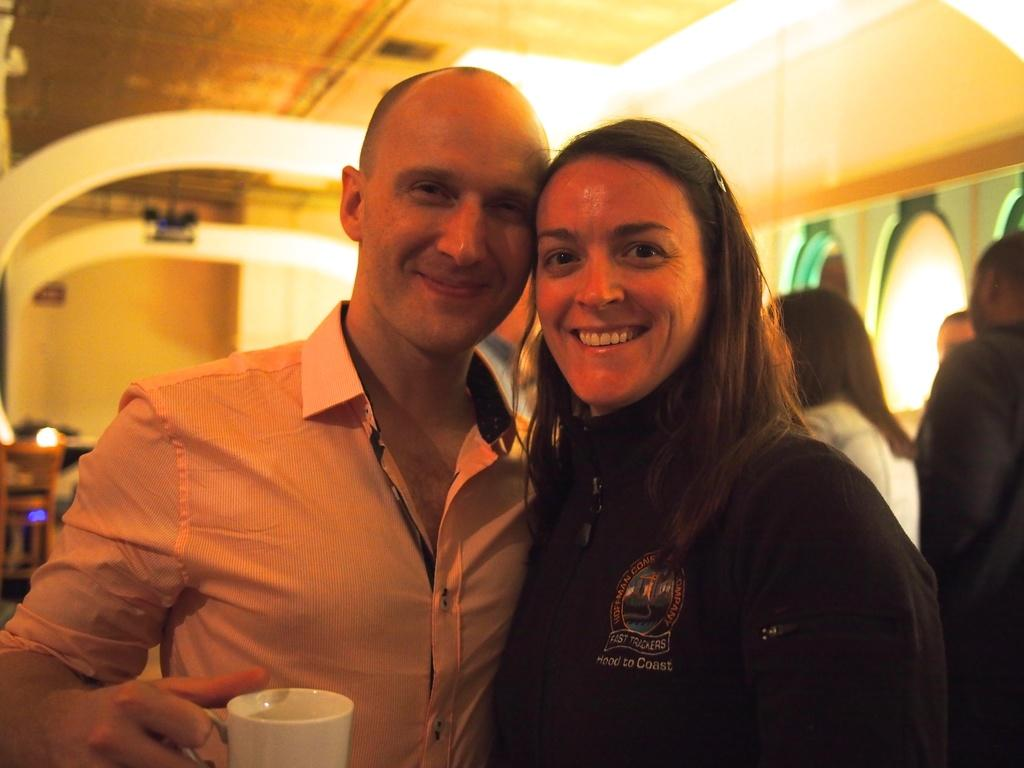What can be seen in the image? There is a group of people in the image. Can you describe the expressions of the people in the image? A man and a woman are smiling in the image. What is the man holding in his hand? The man is holding a cup in his hand. Where is the governor sitting on his throne in the image? There is no governor or throne present in the image. 